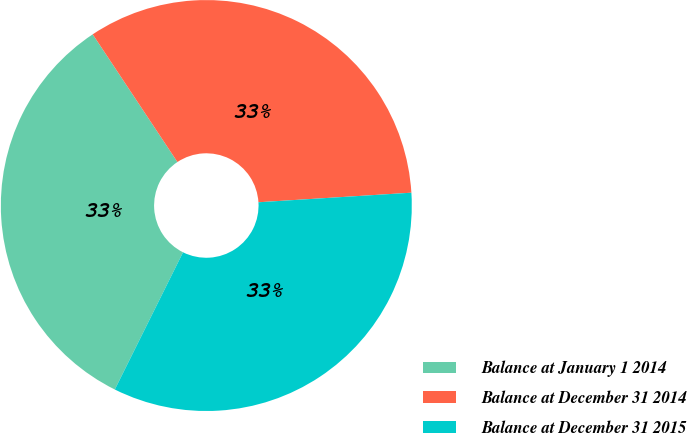<chart> <loc_0><loc_0><loc_500><loc_500><pie_chart><fcel>Balance at January 1 2014<fcel>Balance at December 31 2014<fcel>Balance at December 31 2015<nl><fcel>33.33%<fcel>33.33%<fcel>33.34%<nl></chart> 